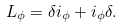Convert formula to latex. <formula><loc_0><loc_0><loc_500><loc_500>L _ { \phi } = \delta i _ { \phi } + i _ { \phi } \delta .</formula> 